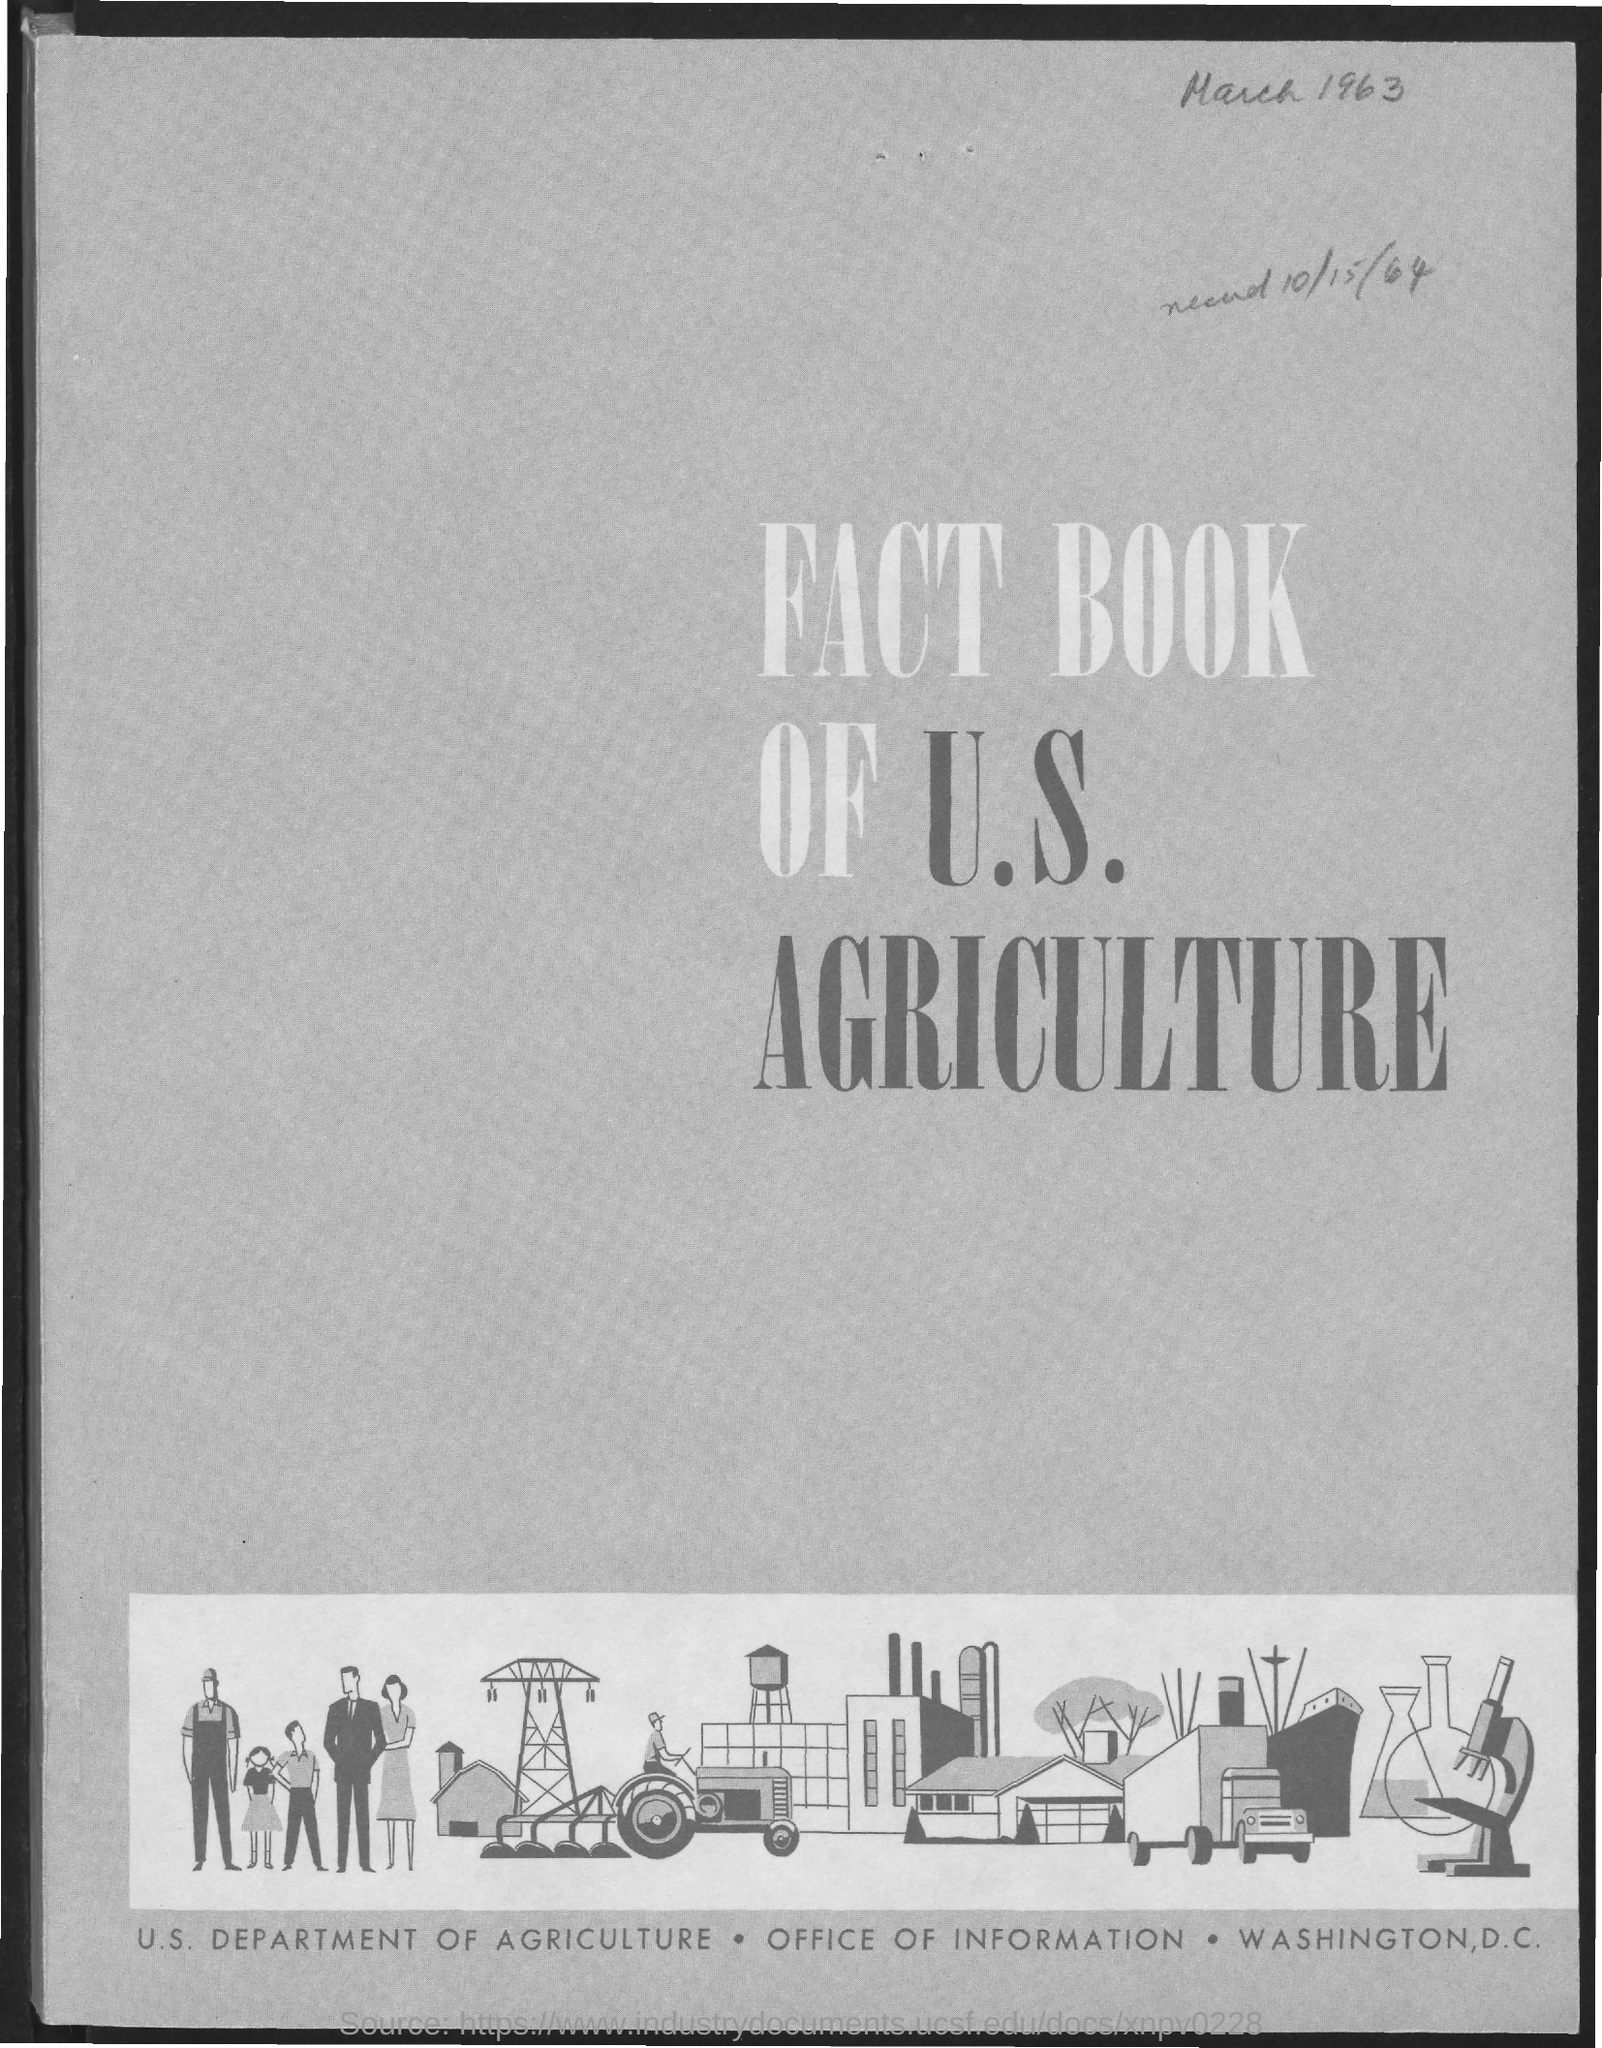What is the fact book about ?
Offer a terse response. FACT BOOK OF U.S. AGRICULTURE. 